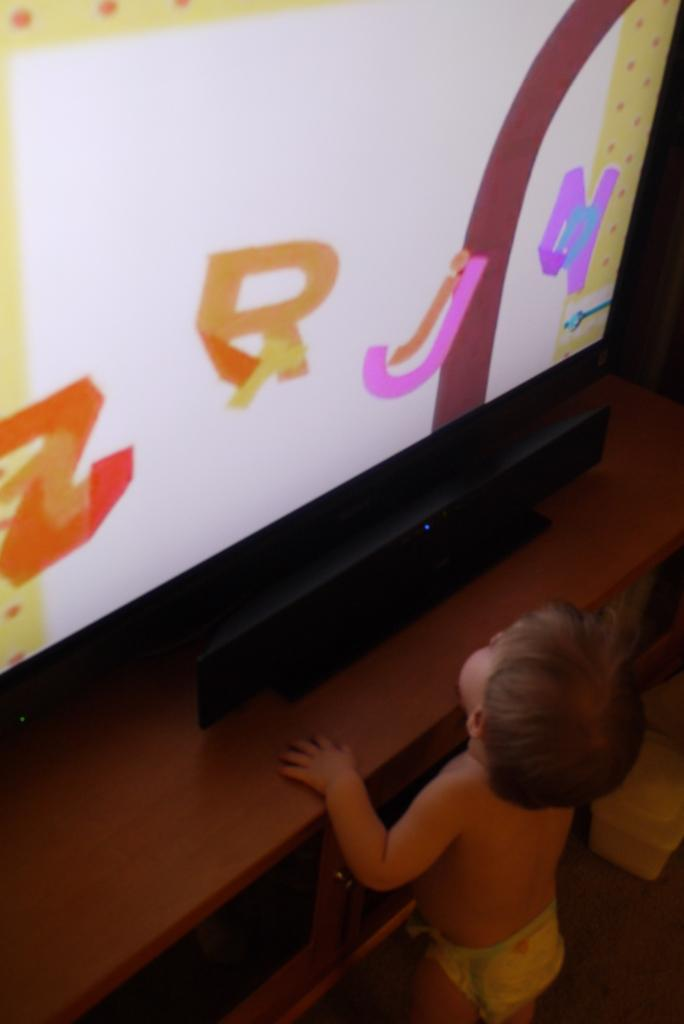Who is the main subject in the image? There is a boy in the image. What is the boy doing in the image? The boy is standing in the image. What is the boy holding in the image? The boy is holding a table in the image. What is on top of the table the boy is holding? There is a television on the table in the image. What type of coal is being used to fuel the air in the image? There is no coal or air present in the image; it features a boy holding a table with a television on it. 